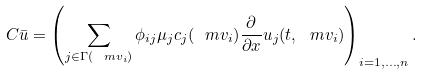Convert formula to latex. <formula><loc_0><loc_0><loc_500><loc_500>C \bar { u } = \left ( \sum _ { j \in \Gamma ( \ m v _ { i } ) } \phi _ { i j } \mu _ { j } c _ { j } ( \ m v _ { i } ) \frac { \partial } { \partial x } u _ { j } ( t , \ m v _ { i } ) \right ) _ { i = 1 , \dots , n } .</formula> 